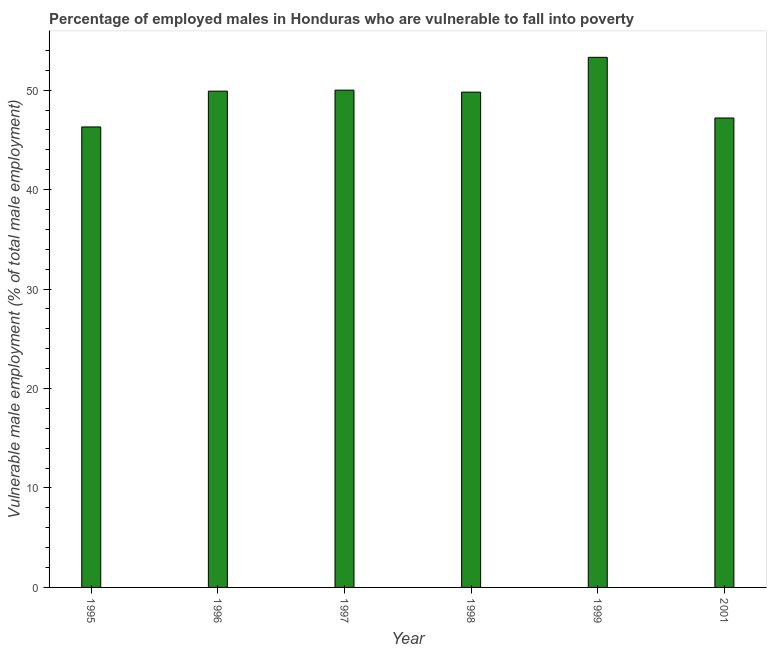Does the graph contain any zero values?
Your answer should be compact. No. What is the title of the graph?
Your response must be concise. Percentage of employed males in Honduras who are vulnerable to fall into poverty. What is the label or title of the X-axis?
Give a very brief answer. Year. What is the label or title of the Y-axis?
Your answer should be compact. Vulnerable male employment (% of total male employment). What is the percentage of employed males who are vulnerable to fall into poverty in 1996?
Your answer should be compact. 49.9. Across all years, what is the maximum percentage of employed males who are vulnerable to fall into poverty?
Keep it short and to the point. 53.3. Across all years, what is the minimum percentage of employed males who are vulnerable to fall into poverty?
Your answer should be very brief. 46.3. In which year was the percentage of employed males who are vulnerable to fall into poverty maximum?
Give a very brief answer. 1999. In which year was the percentage of employed males who are vulnerable to fall into poverty minimum?
Make the answer very short. 1995. What is the sum of the percentage of employed males who are vulnerable to fall into poverty?
Keep it short and to the point. 296.5. What is the difference between the percentage of employed males who are vulnerable to fall into poverty in 1997 and 2001?
Offer a terse response. 2.8. What is the average percentage of employed males who are vulnerable to fall into poverty per year?
Ensure brevity in your answer.  49.42. What is the median percentage of employed males who are vulnerable to fall into poverty?
Your response must be concise. 49.85. In how many years, is the percentage of employed males who are vulnerable to fall into poverty greater than 34 %?
Provide a succinct answer. 6. Do a majority of the years between 1999 and 1995 (inclusive) have percentage of employed males who are vulnerable to fall into poverty greater than 44 %?
Your answer should be very brief. Yes. What is the ratio of the percentage of employed males who are vulnerable to fall into poverty in 1995 to that in 1998?
Provide a short and direct response. 0.93. Is the percentage of employed males who are vulnerable to fall into poverty in 1995 less than that in 1999?
Offer a very short reply. Yes. Is the difference between the percentage of employed males who are vulnerable to fall into poverty in 1995 and 1997 greater than the difference between any two years?
Make the answer very short. No. What is the difference between the highest and the lowest percentage of employed males who are vulnerable to fall into poverty?
Offer a very short reply. 7. How many bars are there?
Keep it short and to the point. 6. Are all the bars in the graph horizontal?
Your response must be concise. No. Are the values on the major ticks of Y-axis written in scientific E-notation?
Ensure brevity in your answer.  No. What is the Vulnerable male employment (% of total male employment) in 1995?
Provide a succinct answer. 46.3. What is the Vulnerable male employment (% of total male employment) in 1996?
Your response must be concise. 49.9. What is the Vulnerable male employment (% of total male employment) of 1998?
Your answer should be compact. 49.8. What is the Vulnerable male employment (% of total male employment) of 1999?
Your answer should be compact. 53.3. What is the Vulnerable male employment (% of total male employment) in 2001?
Provide a short and direct response. 47.2. What is the difference between the Vulnerable male employment (% of total male employment) in 1995 and 1998?
Offer a very short reply. -3.5. What is the difference between the Vulnerable male employment (% of total male employment) in 1996 and 1998?
Your answer should be very brief. 0.1. What is the difference between the Vulnerable male employment (% of total male employment) in 1996 and 1999?
Offer a terse response. -3.4. What is the difference between the Vulnerable male employment (% of total male employment) in 1996 and 2001?
Offer a very short reply. 2.7. What is the difference between the Vulnerable male employment (% of total male employment) in 1997 and 1998?
Give a very brief answer. 0.2. What is the difference between the Vulnerable male employment (% of total male employment) in 1997 and 1999?
Keep it short and to the point. -3.3. What is the ratio of the Vulnerable male employment (% of total male employment) in 1995 to that in 1996?
Provide a short and direct response. 0.93. What is the ratio of the Vulnerable male employment (% of total male employment) in 1995 to that in 1997?
Give a very brief answer. 0.93. What is the ratio of the Vulnerable male employment (% of total male employment) in 1995 to that in 1998?
Offer a terse response. 0.93. What is the ratio of the Vulnerable male employment (% of total male employment) in 1995 to that in 1999?
Provide a succinct answer. 0.87. What is the ratio of the Vulnerable male employment (% of total male employment) in 1996 to that in 1998?
Keep it short and to the point. 1. What is the ratio of the Vulnerable male employment (% of total male employment) in 1996 to that in 1999?
Provide a short and direct response. 0.94. What is the ratio of the Vulnerable male employment (% of total male employment) in 1996 to that in 2001?
Make the answer very short. 1.06. What is the ratio of the Vulnerable male employment (% of total male employment) in 1997 to that in 1999?
Your answer should be very brief. 0.94. What is the ratio of the Vulnerable male employment (% of total male employment) in 1997 to that in 2001?
Keep it short and to the point. 1.06. What is the ratio of the Vulnerable male employment (% of total male employment) in 1998 to that in 1999?
Ensure brevity in your answer.  0.93. What is the ratio of the Vulnerable male employment (% of total male employment) in 1998 to that in 2001?
Your response must be concise. 1.05. What is the ratio of the Vulnerable male employment (% of total male employment) in 1999 to that in 2001?
Keep it short and to the point. 1.13. 